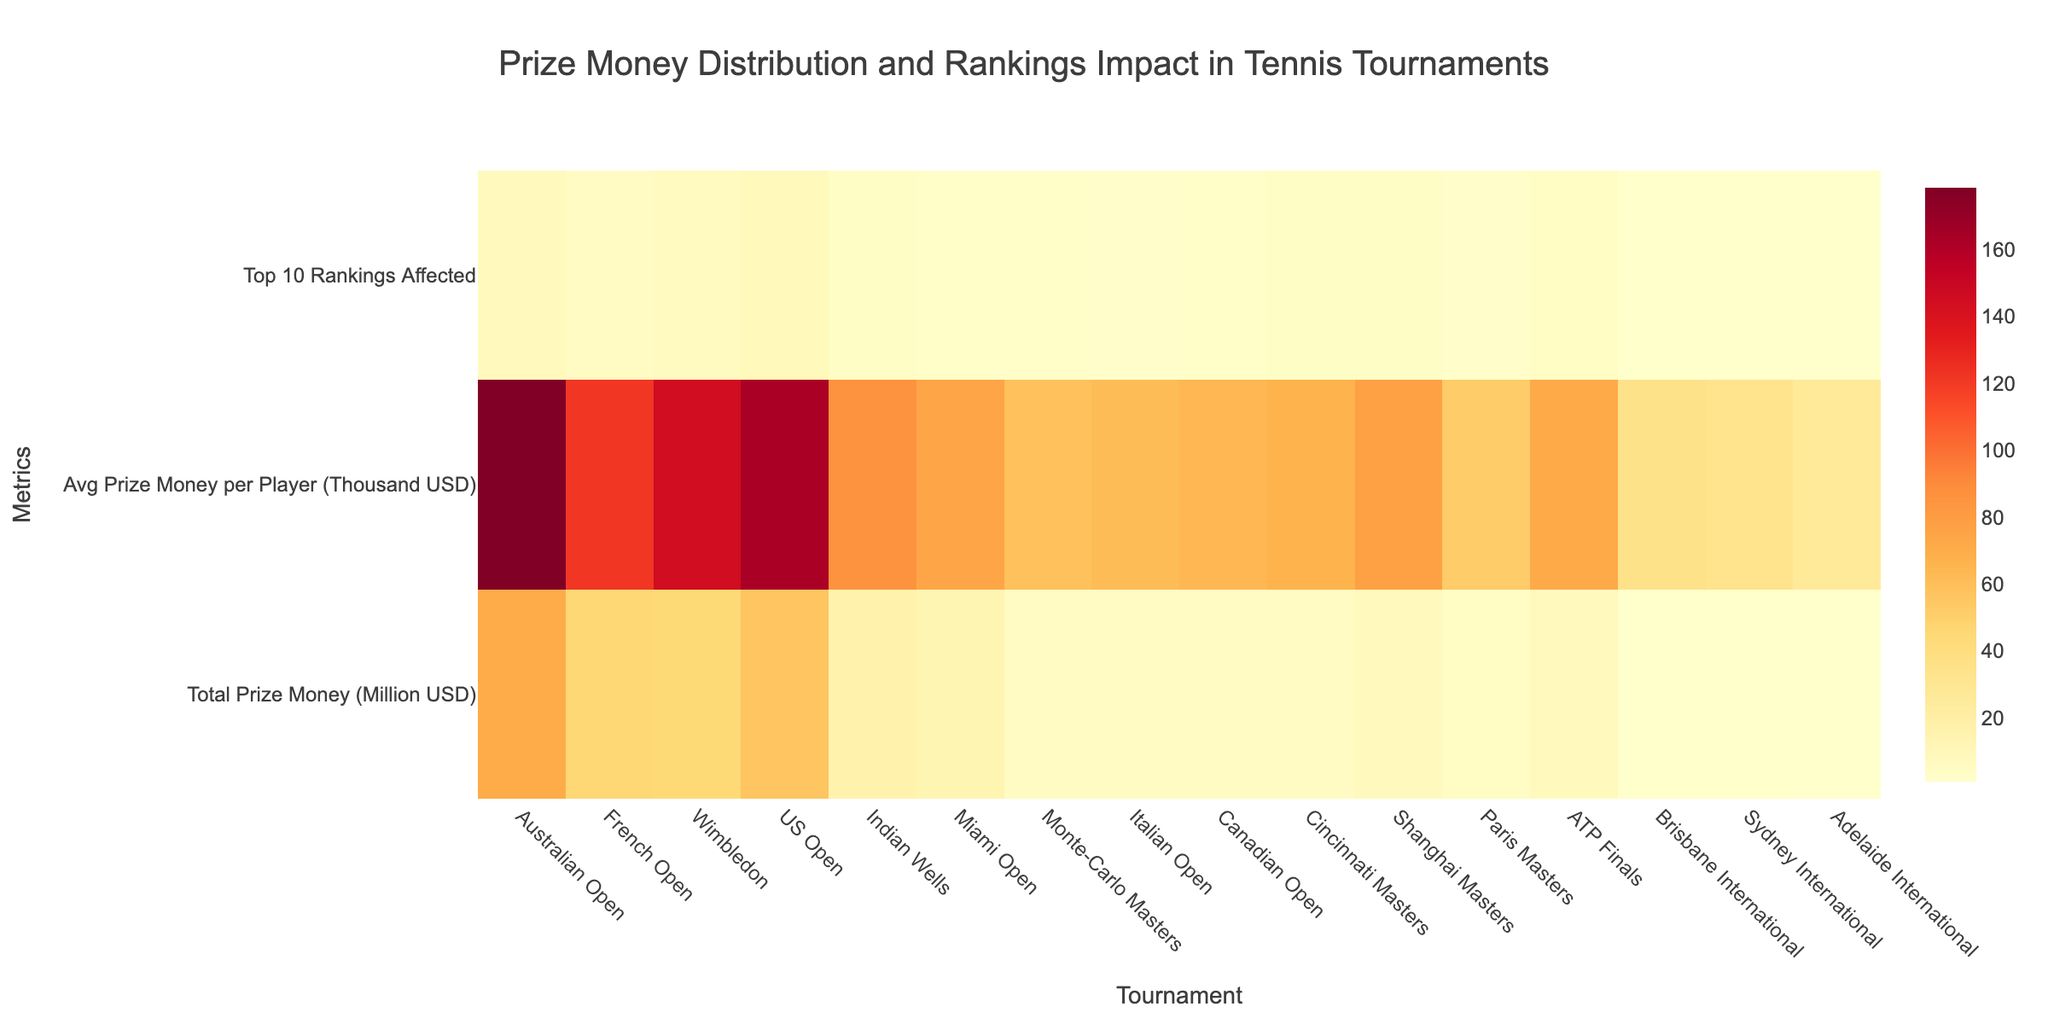what's the title of the heatmap? The heatmap title is located at the top center of the figure. It reads: "Prize Money Distribution and Rankings Impact in Tennis Tournaments"
Answer: Prize Money Distribution and Rankings Impact in Tennis Tournaments which tournament has the highest total prize money? By checking the row labeled 'Total Prize Money (Million USD)' and comparing the values for each tournament, the Australian Open has the highest total prize money of 71 million USD
Answer: Australian Open How many tournaments affect the top 10 rankings by impacting at least 5 players? Viewing the row labeled 'Top 10 Rankings Affected', count the number of tournaments with values of 5 or greater. These tournaments are: Australian Open (8), French Open (6), Wimbledon (7), US Open (9), and ATP Finals (5)
Answer: 5 What's the color scale used in the heatmap? The color scale is displayed to the side of the heatmap. It ranges from light yellow (low value) to dark red (high value)
Answer: YlOrRd Which tournament has the lowest average prize money per player? Looking at the row 'Avg Prize Money per Player (Thousand USD)' and finding the smallest value, Adelaide International has the lowest average prize money per player of 27 thousand USD
Answer: Adelaide International What's the difference in total prize money between the US Open and Wimbledon? Checking the total prize money in million USD for both tournaments: US Open (57) and Wimbledon (44.7). The difference is calculated as 57 - 44.7
Answer: 12.3 million USD Which tournament impacts the top 10 rankings the most? From the row 'Top 10 Rankings Affected', identify the tournament with the highest value. The US Open impacts the rankings the most with a value of 9
Answer: US Open Compare the average prize money per player between Indian Wells and Miami Open. Which one is higher and by how much? Observing the 'Avg Prize Money per Player (Thousand USD)' row, Indian Wells has 86 and Miami Open has 75. The difference is calculated as 86 - 75
Answer: Indian Wells by 11 thousand USD How does the total prize money at Brisbane International compare to Sydney International? Checking the total prize money for both tournaments in million USD: Brisbane International (1.57572) and Sydney International (1.5). Brisbane International is higher
Answer: Brisbane International What is the sum of the total prize money for the Grand Slam tournaments (Australian Open, French Open, Wimbledon, US Open)? Summing the total prize money (million USD) for Australian Open (71), French Open (46), Wimbledon (44.7), US Open (57). The total is 71 + 46 + 44.7 + 57
Answer: 218.7 million USD 